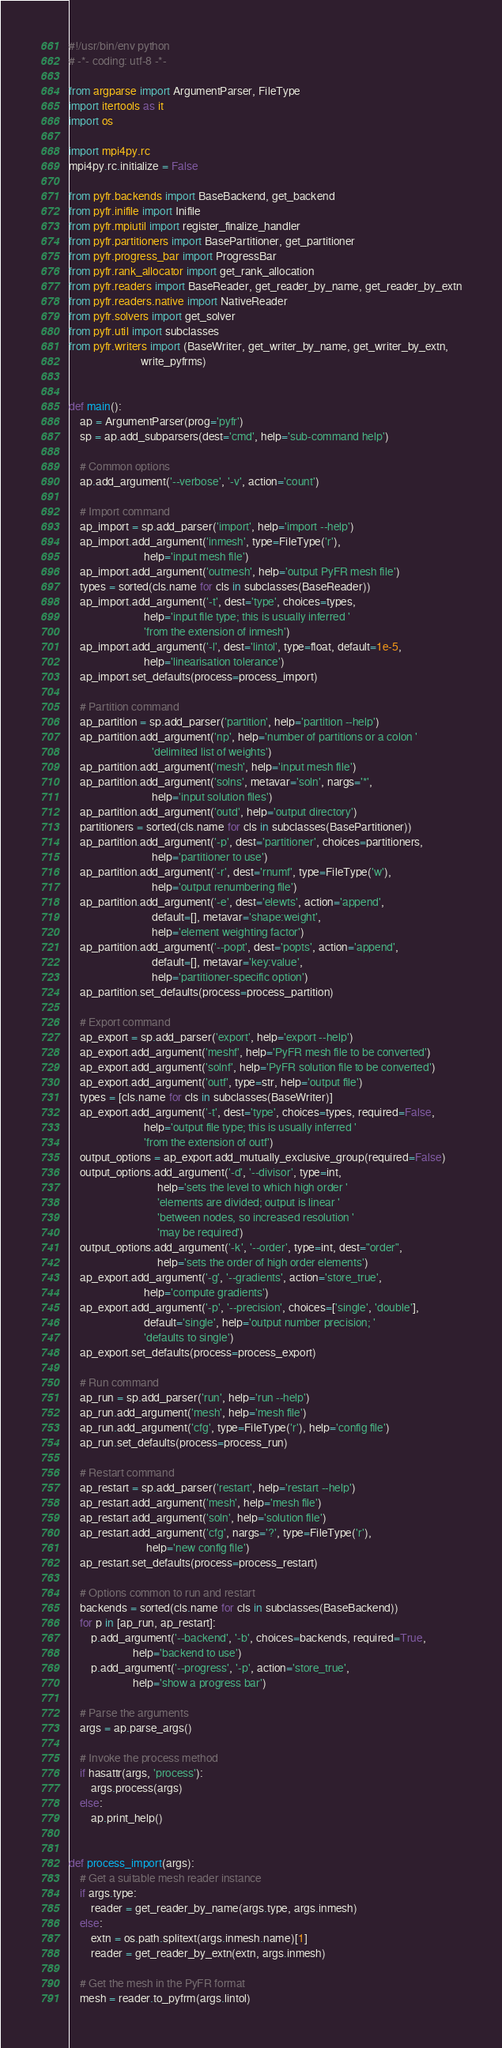<code> <loc_0><loc_0><loc_500><loc_500><_Python_>#!/usr/bin/env python
# -*- coding: utf-8 -*-

from argparse import ArgumentParser, FileType
import itertools as it
import os

import mpi4py.rc
mpi4py.rc.initialize = False

from pyfr.backends import BaseBackend, get_backend
from pyfr.inifile import Inifile
from pyfr.mpiutil import register_finalize_handler
from pyfr.partitioners import BasePartitioner, get_partitioner
from pyfr.progress_bar import ProgressBar
from pyfr.rank_allocator import get_rank_allocation
from pyfr.readers import BaseReader, get_reader_by_name, get_reader_by_extn
from pyfr.readers.native import NativeReader
from pyfr.solvers import get_solver
from pyfr.util import subclasses
from pyfr.writers import (BaseWriter, get_writer_by_name, get_writer_by_extn,
                          write_pyfrms)


def main():
    ap = ArgumentParser(prog='pyfr')
    sp = ap.add_subparsers(dest='cmd', help='sub-command help')

    # Common options
    ap.add_argument('--verbose', '-v', action='count')

    # Import command
    ap_import = sp.add_parser('import', help='import --help')
    ap_import.add_argument('inmesh', type=FileType('r'),
                           help='input mesh file')
    ap_import.add_argument('outmesh', help='output PyFR mesh file')
    types = sorted(cls.name for cls in subclasses(BaseReader))
    ap_import.add_argument('-t', dest='type', choices=types,
                           help='input file type; this is usually inferred '
                           'from the extension of inmesh')
    ap_import.add_argument('-l', dest='lintol', type=float, default=1e-5,
                           help='linearisation tolerance')
    ap_import.set_defaults(process=process_import)

    # Partition command
    ap_partition = sp.add_parser('partition', help='partition --help')
    ap_partition.add_argument('np', help='number of partitions or a colon '
                              'delimited list of weights')
    ap_partition.add_argument('mesh', help='input mesh file')
    ap_partition.add_argument('solns', metavar='soln', nargs='*',
                              help='input solution files')
    ap_partition.add_argument('outd', help='output directory')
    partitioners = sorted(cls.name for cls in subclasses(BasePartitioner))
    ap_partition.add_argument('-p', dest='partitioner', choices=partitioners,
                              help='partitioner to use')
    ap_partition.add_argument('-r', dest='rnumf', type=FileType('w'),
                              help='output renumbering file')
    ap_partition.add_argument('-e', dest='elewts', action='append',
                              default=[], metavar='shape:weight',
                              help='element weighting factor')
    ap_partition.add_argument('--popt', dest='popts', action='append',
                              default=[], metavar='key:value',
                              help='partitioner-specific option')
    ap_partition.set_defaults(process=process_partition)

    # Export command
    ap_export = sp.add_parser('export', help='export --help')
    ap_export.add_argument('meshf', help='PyFR mesh file to be converted')
    ap_export.add_argument('solnf', help='PyFR solution file to be converted')
    ap_export.add_argument('outf', type=str, help='output file')
    types = [cls.name for cls in subclasses(BaseWriter)]
    ap_export.add_argument('-t', dest='type', choices=types, required=False,
                           help='output file type; this is usually inferred '
                           'from the extension of outf')
    output_options = ap_export.add_mutually_exclusive_group(required=False)
    output_options.add_argument('-d', '--divisor', type=int,
                                help='sets the level to which high order '
                                'elements are divided; output is linear '
                                'between nodes, so increased resolution '
                                'may be required')
    output_options.add_argument('-k', '--order', type=int, dest="order",
                                help='sets the order of high order elements')
    ap_export.add_argument('-g', '--gradients', action='store_true',
                           help='compute gradients')
    ap_export.add_argument('-p', '--precision', choices=['single', 'double'],
                           default='single', help='output number precision; '
                           'defaults to single')
    ap_export.set_defaults(process=process_export)

    # Run command
    ap_run = sp.add_parser('run', help='run --help')
    ap_run.add_argument('mesh', help='mesh file')
    ap_run.add_argument('cfg', type=FileType('r'), help='config file')
    ap_run.set_defaults(process=process_run)

    # Restart command
    ap_restart = sp.add_parser('restart', help='restart --help')
    ap_restart.add_argument('mesh', help='mesh file')
    ap_restart.add_argument('soln', help='solution file')
    ap_restart.add_argument('cfg', nargs='?', type=FileType('r'),
                            help='new config file')
    ap_restart.set_defaults(process=process_restart)

    # Options common to run and restart
    backends = sorted(cls.name for cls in subclasses(BaseBackend))
    for p in [ap_run, ap_restart]:
        p.add_argument('--backend', '-b', choices=backends, required=True,
                       help='backend to use')
        p.add_argument('--progress', '-p', action='store_true',
                       help='show a progress bar')

    # Parse the arguments
    args = ap.parse_args()

    # Invoke the process method
    if hasattr(args, 'process'):
        args.process(args)
    else:
        ap.print_help()


def process_import(args):
    # Get a suitable mesh reader instance
    if args.type:
        reader = get_reader_by_name(args.type, args.inmesh)
    else:
        extn = os.path.splitext(args.inmesh.name)[1]
        reader = get_reader_by_extn(extn, args.inmesh)

    # Get the mesh in the PyFR format
    mesh = reader.to_pyfrm(args.lintol)
</code> 